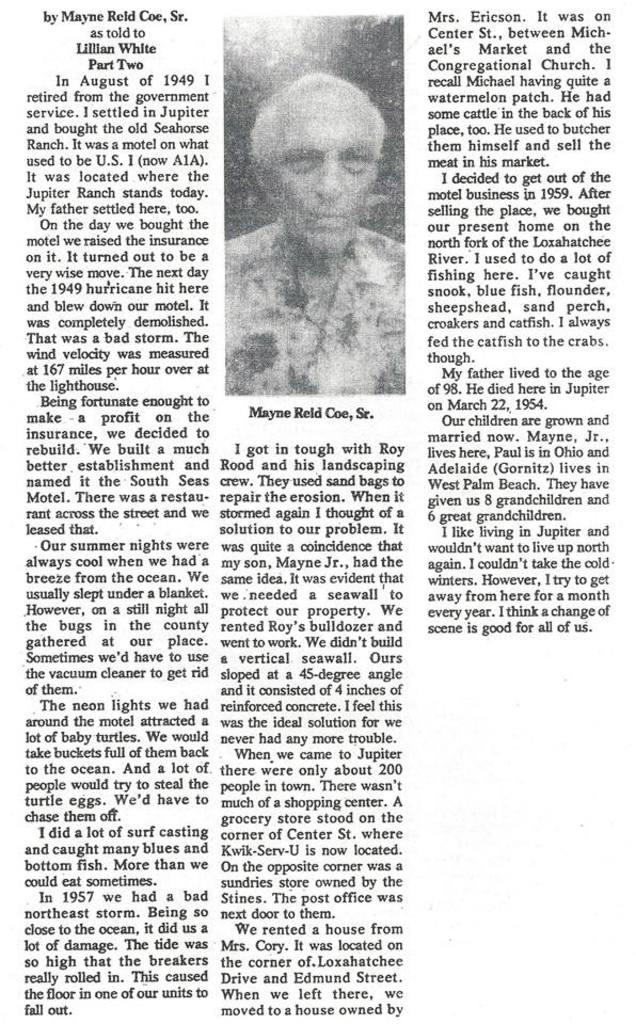What is the main subject of the image? There is a photo of a man in the image. What is the man wearing in the photo? There is a garland on the man's neck in the photo. Is there any text visible in the image? Yes, there is text visible in the image. Can you see any fangs on the man in the photo? There are no fangs visible on the man in the photo. Is there a drum being played in the image? There is no drum or indication of music being played in the image. 